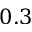<formula> <loc_0><loc_0><loc_500><loc_500>0 . 3</formula> 